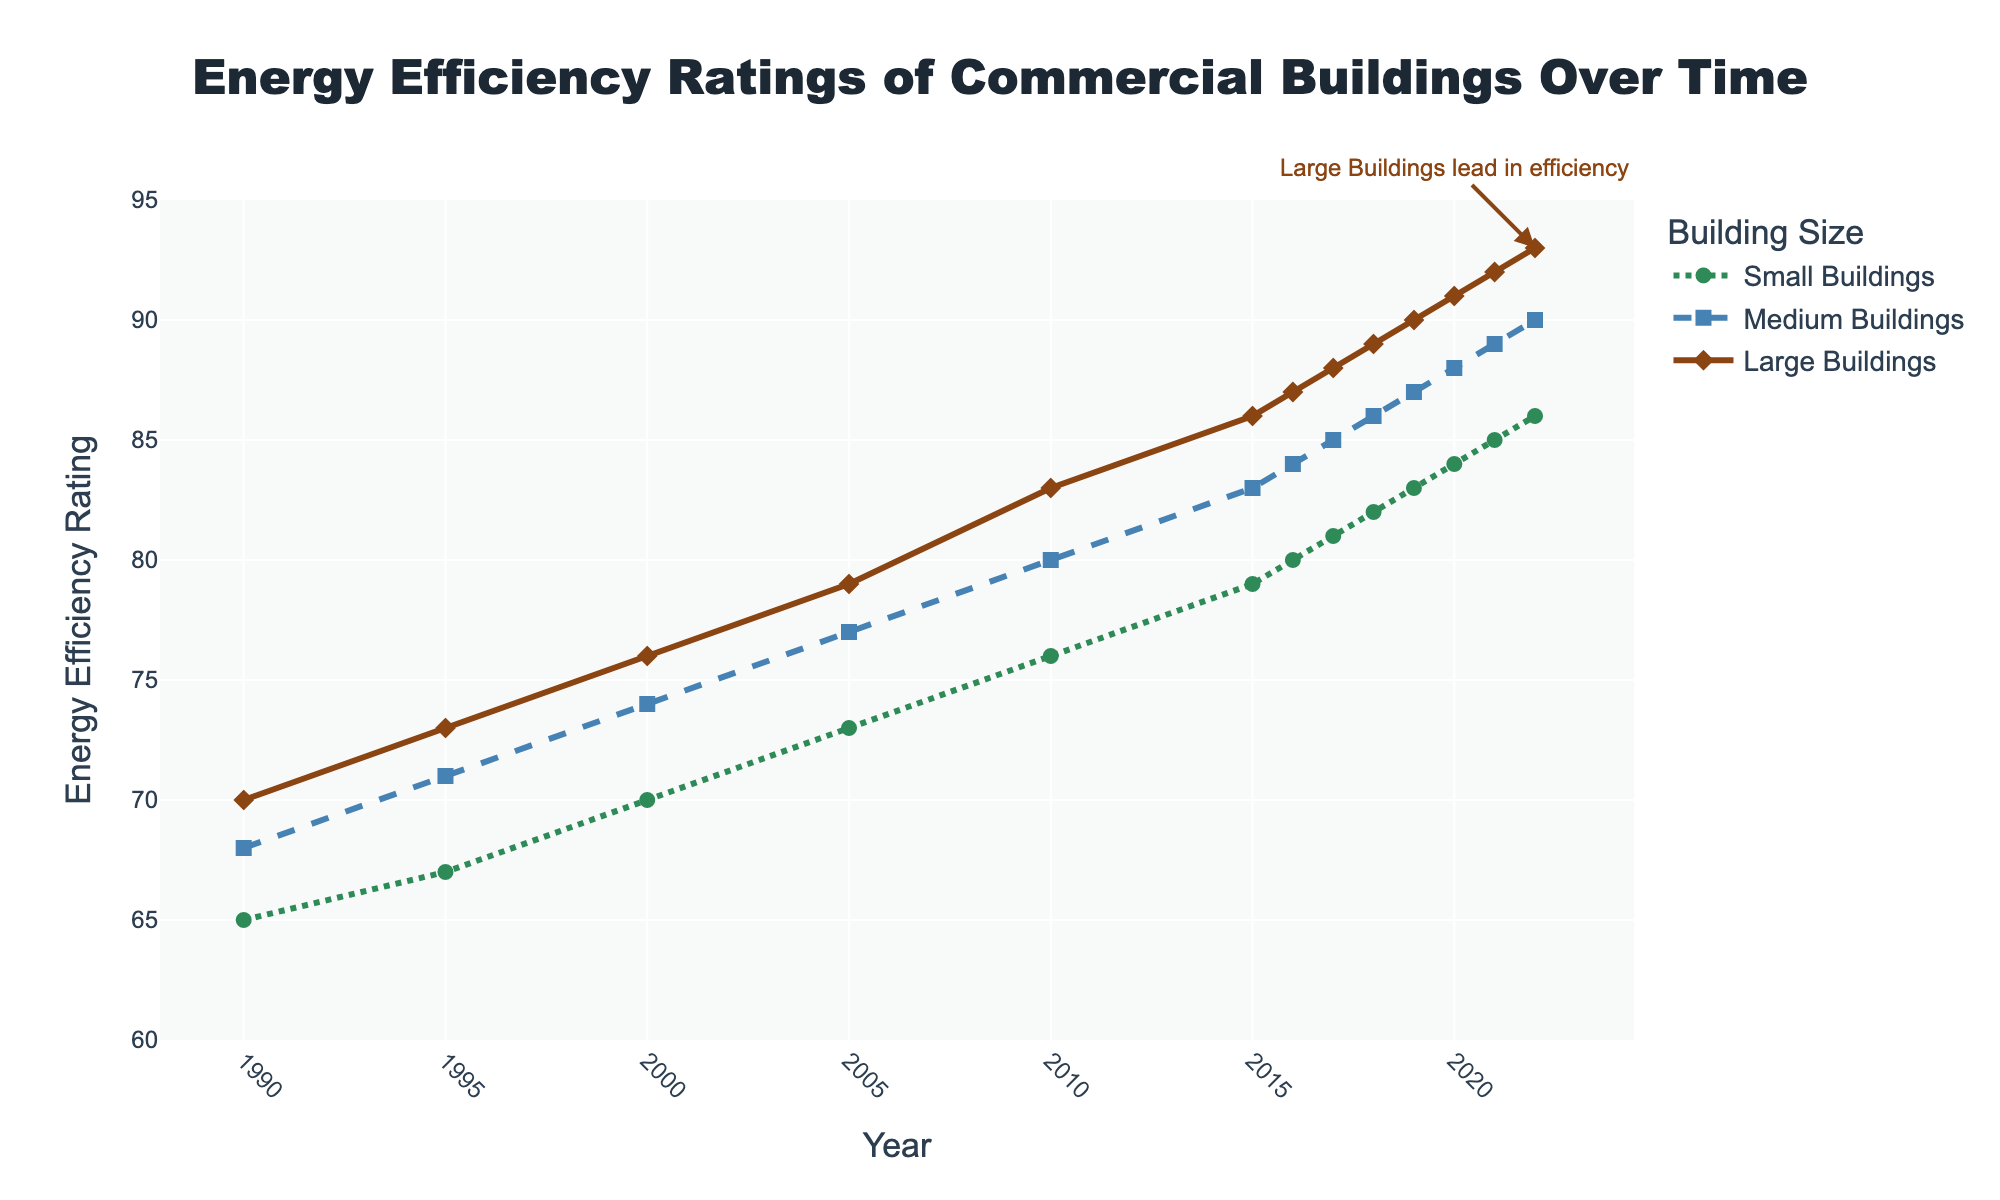What is the energy efficiency rating of small buildings in 2015? Locate the year 2015 on the x-axis and find the corresponding value for the green dotted line representing small buildings.
Answer: 79 Which category of buildings had the highest energy efficiency rating in 2022? Locate the year 2022 on the x-axis and identify which line reaches the highest point.
Answer: Large Buildings By how much did the energy efficiency rating of medium buildings increase from 1990 to 2022? Subtract the energy efficiency rating of medium buildings in 1990 from the rating in 2022 (90 - 68).
Answer: 22 What trend can be observed in the energy efficiency ratings of all building sizes from 1990 to 2022? Each line shows a positive slope from 1990 to 2022, indicating an increase in energy efficiency ratings over time for all building sizes.
Answer: Increasing Compare the energy efficiency ratings between medium and large buildings in 2010. Which is higher? Locate the year 2010 on the x-axis and compare the values for the blue dashed line (medium) and the solid brown line (large).
Answer: Large Buildings What is the average energy efficiency rating of large buildings between 2015 and 2022? Sum the values of large buildings from 2015 to 2022 and divide by the number of years: (86 + 87 + 88 + 89 + 90 + 91 + 92 + 93) / 8.
Answer: 89.5 How does the visual distinction between the lines help in identifying different building sizes? Each line is uniquely styled: green dotted for small buildings, blue dashed for medium buildings, and solid brown for large buildings.
Answer: Unique line styles Between which consecutive years did small buildings see the largest increase in energy efficiency? Calculate the differences between each consecutive year's rating for small buildings and find the maximum: (67-65), (70-67), (73-70), etc. The largest increase is between 2019 and 2020 (84-83).
Answer: 2019 to 2020 Is there any year where the energy efficiency ratings of medium and large buildings are equal? Scan across the x-axis and compare values at each year for the blue dashed line and the solid brown line. None of the years have equal ratings for both categories.
Answer: No Which building size had the smallest improvement in energy efficiency from 1990 to 2000? Compare the increases for each building size from 1990 to 2000: small (70-65 = 5), medium (74-68 = 6), large (76-70 = 6). Small buildings had the smallest increase.
Answer: Small Buildings 